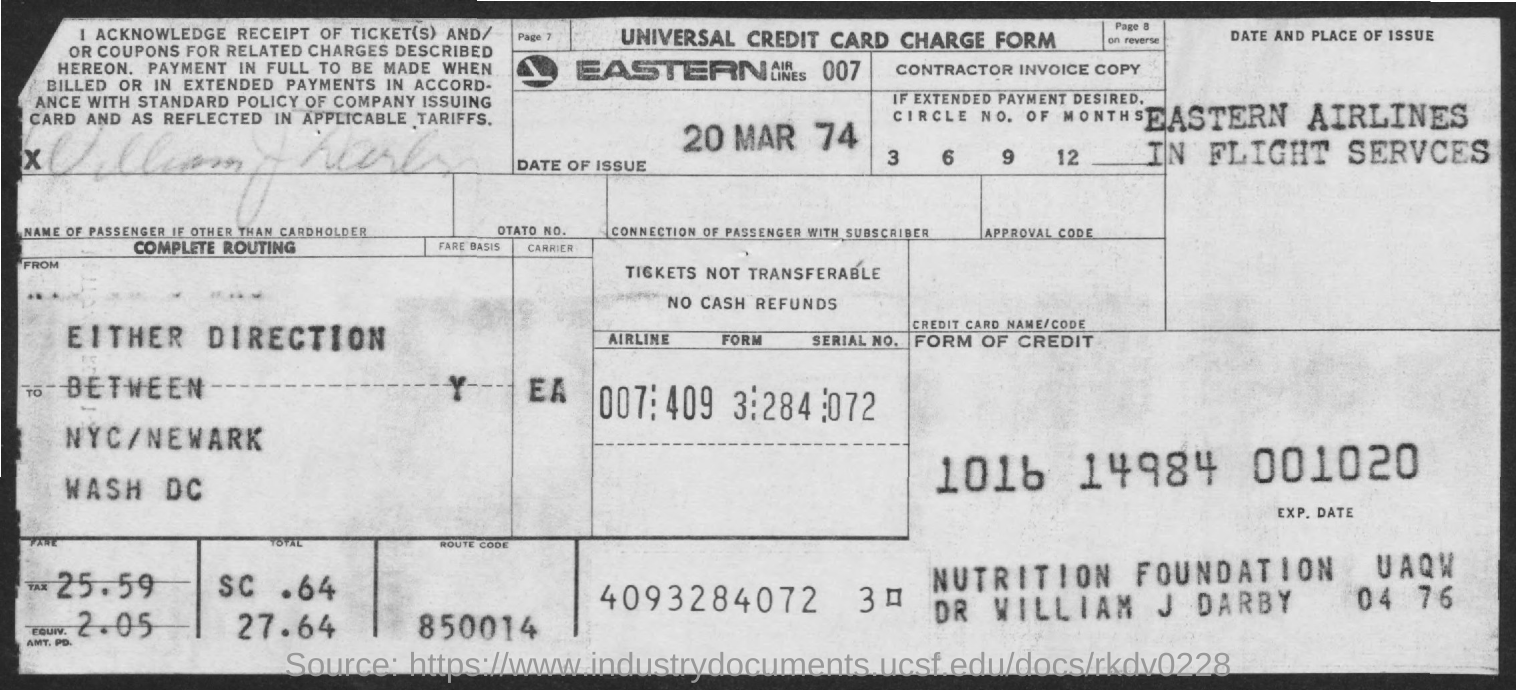Identify some key points in this picture. The date of issue is March 20, 1974. What is the route code mentioned? It is 850014. Eastern Airlines, designated as 007, is the name of a well-established airline company. 